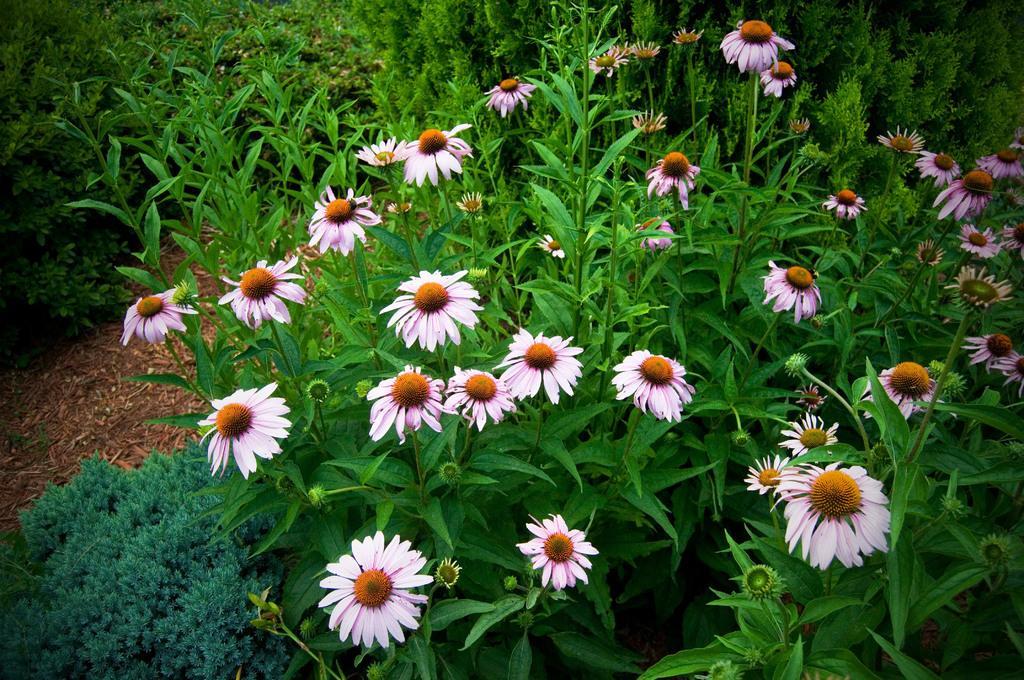Please provide a concise description of this image. In this image we can see flowers on the plants. Also there are many other plants. 